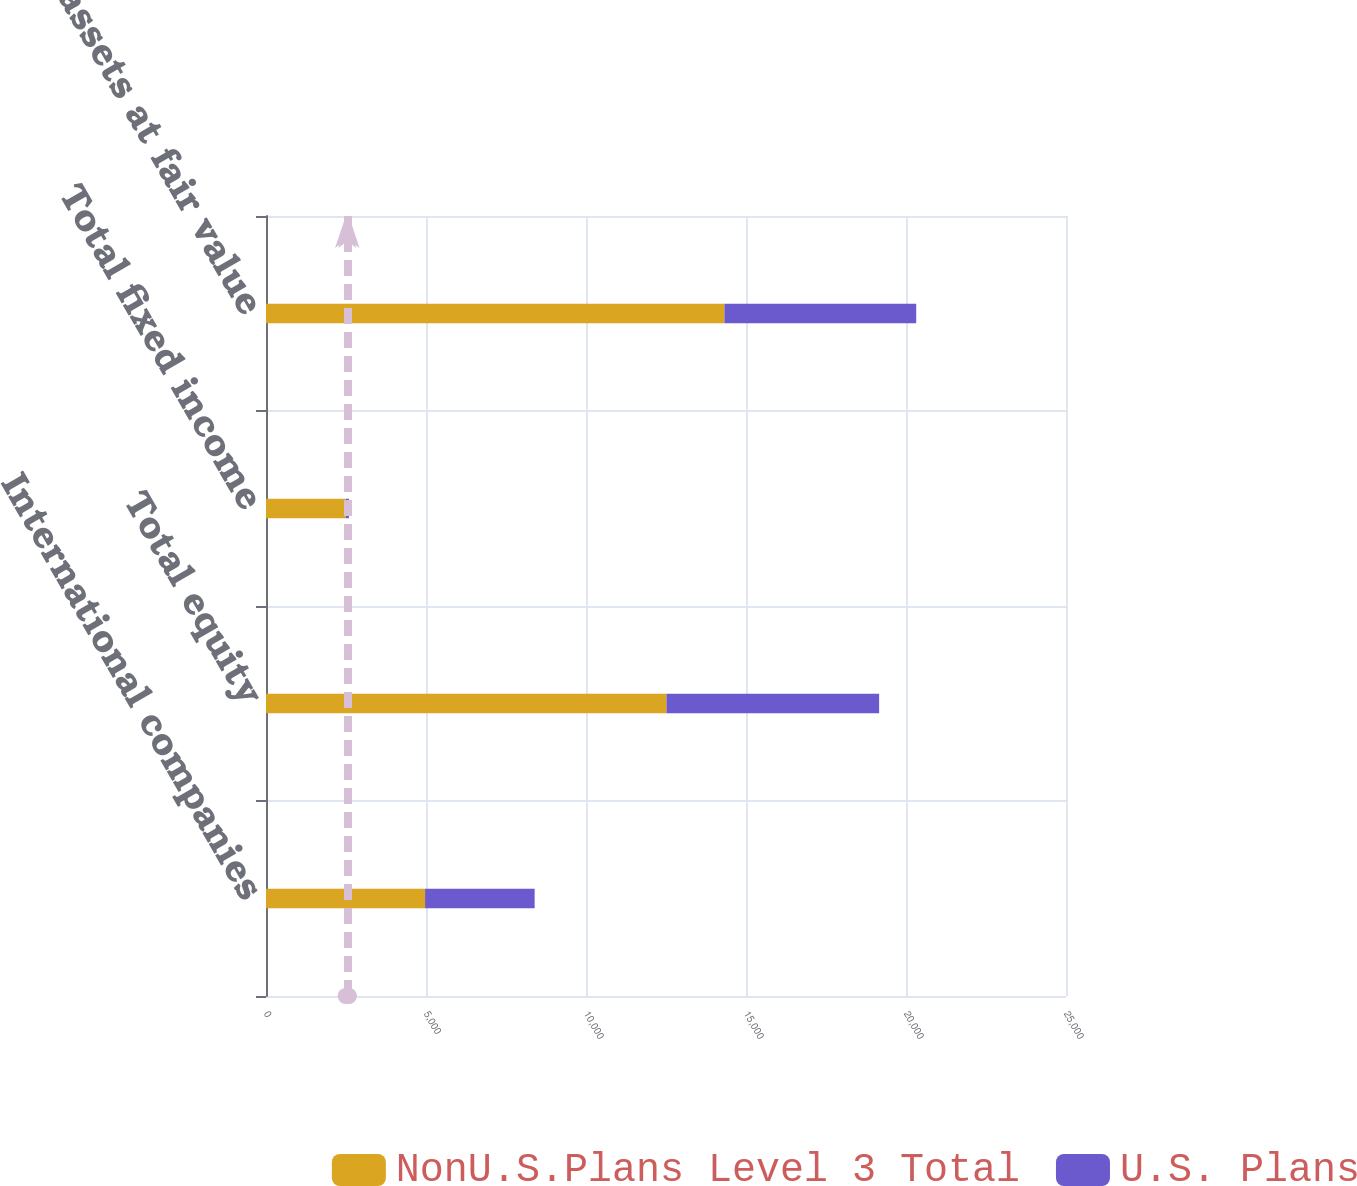<chart> <loc_0><loc_0><loc_500><loc_500><stacked_bar_chart><ecel><fcel>International companies<fcel>Total equity<fcel>Total fixed income<fcel>Total assets at fair value<nl><fcel>NonU.S.Plans Level 3 Total<fcel>4971<fcel>12515<fcel>2492<fcel>14326<nl><fcel>U.S. Plans<fcel>3424<fcel>6645<fcel>99<fcel>5993<nl></chart> 